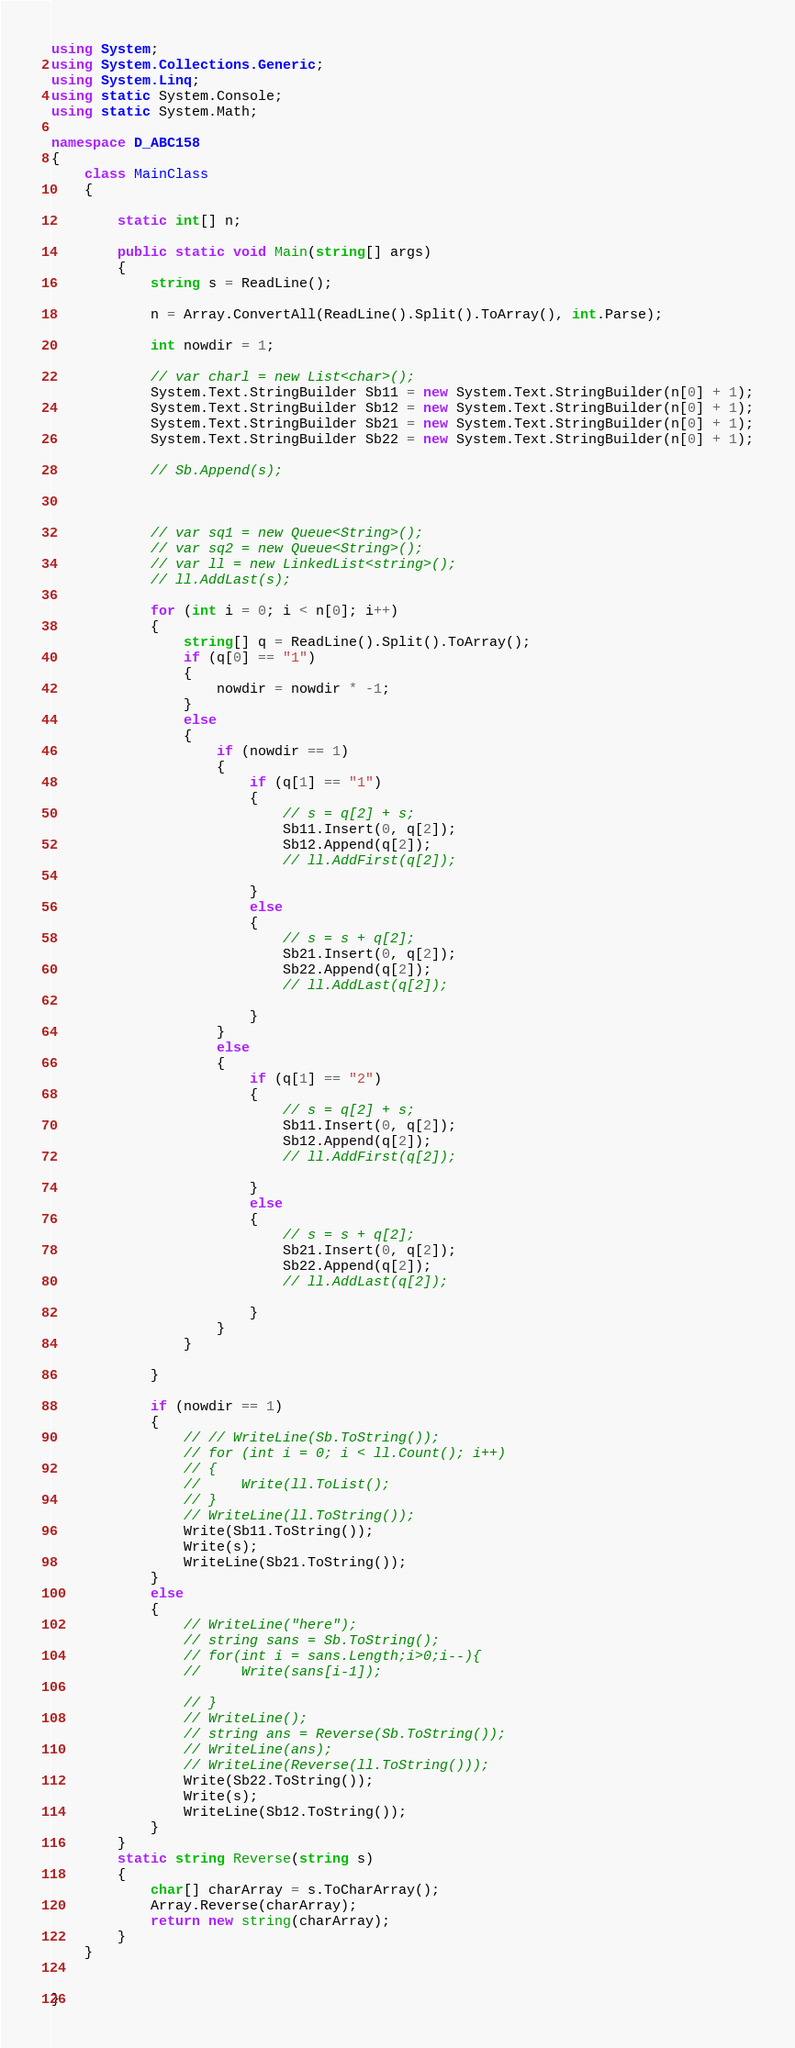<code> <loc_0><loc_0><loc_500><loc_500><_C#_>using System;
using System.Collections.Generic;
using System.Linq;
using static System.Console;
using static System.Math;

namespace D_ABC158
{
    class MainClass
    {

        static int[] n;

        public static void Main(string[] args)
        {
            string s = ReadLine();

            n = Array.ConvertAll(ReadLine().Split().ToArray(), int.Parse);

            int nowdir = 1;

            // var charl = new List<char>();
            System.Text.StringBuilder Sb11 = new System.Text.StringBuilder(n[0] + 1);
            System.Text.StringBuilder Sb12 = new System.Text.StringBuilder(n[0] + 1);
            System.Text.StringBuilder Sb21 = new System.Text.StringBuilder(n[0] + 1);
            System.Text.StringBuilder Sb22 = new System.Text.StringBuilder(n[0] + 1);

            // Sb.Append(s);



            // var sq1 = new Queue<String>();
            // var sq2 = new Queue<String>();
            // var ll = new LinkedList<string>();
            // ll.AddLast(s);

            for (int i = 0; i < n[0]; i++)
            {
                string[] q = ReadLine().Split().ToArray();
                if (q[0] == "1")
                {
                    nowdir = nowdir * -1;
                }
                else
                {
                    if (nowdir == 1)
                    {
                        if (q[1] == "1")
                        {
                            // s = q[2] + s;
                            Sb11.Insert(0, q[2]);
                            Sb12.Append(q[2]);
                            // ll.AddFirst(q[2]);

                        }
                        else
                        {
                            // s = s + q[2];
                            Sb21.Insert(0, q[2]);
                            Sb22.Append(q[2]);
                            // ll.AddLast(q[2]);

                        }
                    }
                    else
                    {
                        if (q[1] == "2")
                        {
                            // s = q[2] + s;
                            Sb11.Insert(0, q[2]);
                            Sb12.Append(q[2]);
                            // ll.AddFirst(q[2]);

                        }
                        else
                        {
                            // s = s + q[2];
                            Sb21.Insert(0, q[2]);
                            Sb22.Append(q[2]);
                            // ll.AddLast(q[2]);

                        }
                    }
                }

            }

            if (nowdir == 1)
            {
                // // WriteLine(Sb.ToString());
                // for (int i = 0; i < ll.Count(); i++)
                // {
                //     Write(ll.ToList();
                // }
                // WriteLine(ll.ToString());
                Write(Sb11.ToString());
                Write(s);
                WriteLine(Sb21.ToString());
            }
            else
            {
                // WriteLine("here");
                // string sans = Sb.ToString();
                // for(int i = sans.Length;i>0;i--){
                //     Write(sans[i-1]);

                // }
                // WriteLine();
                // string ans = Reverse(Sb.ToString());
                // WriteLine(ans);
                // WriteLine(Reverse(ll.ToString()));
                Write(Sb22.ToString());
                Write(s);
                WriteLine(Sb12.ToString());
            }
        }
        static string Reverse(string s)
        {
            char[] charArray = s.ToCharArray();
            Array.Reverse(charArray);
            return new string(charArray);
        }
    }


}
</code> 